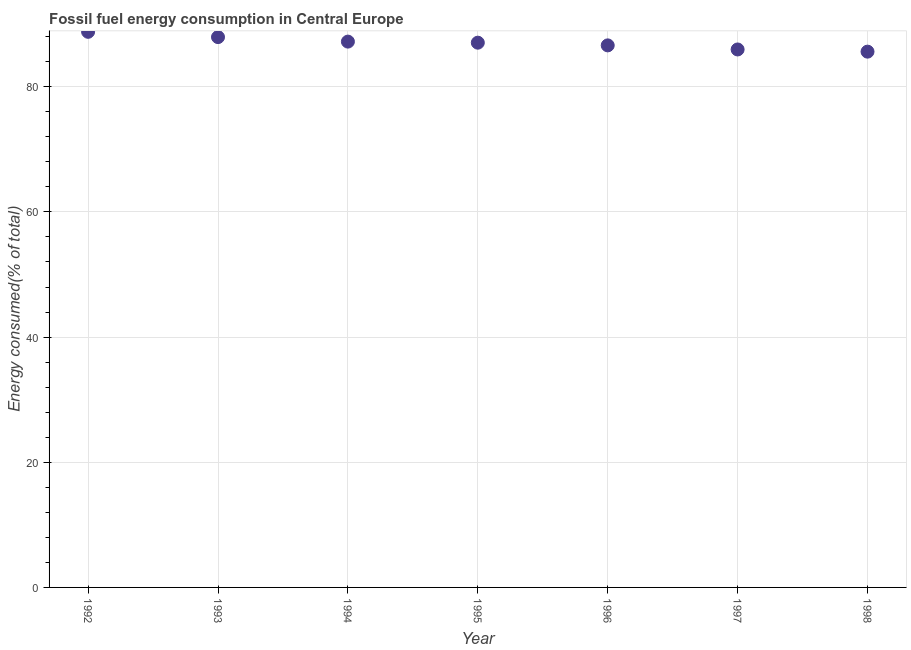What is the fossil fuel energy consumption in 1996?
Ensure brevity in your answer.  86.61. Across all years, what is the maximum fossil fuel energy consumption?
Your answer should be compact. 88.77. Across all years, what is the minimum fossil fuel energy consumption?
Provide a succinct answer. 85.61. In which year was the fossil fuel energy consumption minimum?
Give a very brief answer. 1998. What is the sum of the fossil fuel energy consumption?
Your answer should be very brief. 609.12. What is the difference between the fossil fuel energy consumption in 1993 and 1998?
Keep it short and to the point. 2.32. What is the average fossil fuel energy consumption per year?
Your response must be concise. 87.02. What is the median fossil fuel energy consumption?
Provide a short and direct response. 87.04. Do a majority of the years between 1995 and 1993 (inclusive) have fossil fuel energy consumption greater than 24 %?
Provide a short and direct response. No. What is the ratio of the fossil fuel energy consumption in 1994 to that in 1998?
Ensure brevity in your answer.  1.02. Is the fossil fuel energy consumption in 1992 less than that in 1994?
Your response must be concise. No. Is the difference between the fossil fuel energy consumption in 1996 and 1997 greater than the difference between any two years?
Keep it short and to the point. No. What is the difference between the highest and the second highest fossil fuel energy consumption?
Provide a short and direct response. 0.84. What is the difference between the highest and the lowest fossil fuel energy consumption?
Make the answer very short. 3.17. Does the fossil fuel energy consumption monotonically increase over the years?
Offer a terse response. No. How many years are there in the graph?
Your answer should be very brief. 7. What is the difference between two consecutive major ticks on the Y-axis?
Provide a short and direct response. 20. Does the graph contain any zero values?
Your answer should be compact. No. What is the title of the graph?
Your answer should be compact. Fossil fuel energy consumption in Central Europe. What is the label or title of the Y-axis?
Give a very brief answer. Energy consumed(% of total). What is the Energy consumed(% of total) in 1992?
Your answer should be very brief. 88.77. What is the Energy consumed(% of total) in 1993?
Offer a terse response. 87.93. What is the Energy consumed(% of total) in 1994?
Offer a terse response. 87.21. What is the Energy consumed(% of total) in 1995?
Your answer should be very brief. 87.04. What is the Energy consumed(% of total) in 1996?
Offer a terse response. 86.61. What is the Energy consumed(% of total) in 1997?
Provide a short and direct response. 85.95. What is the Energy consumed(% of total) in 1998?
Keep it short and to the point. 85.61. What is the difference between the Energy consumed(% of total) in 1992 and 1993?
Your answer should be compact. 0.84. What is the difference between the Energy consumed(% of total) in 1992 and 1994?
Your response must be concise. 1.56. What is the difference between the Energy consumed(% of total) in 1992 and 1995?
Offer a terse response. 1.73. What is the difference between the Energy consumed(% of total) in 1992 and 1996?
Provide a succinct answer. 2.17. What is the difference between the Energy consumed(% of total) in 1992 and 1997?
Your answer should be very brief. 2.82. What is the difference between the Energy consumed(% of total) in 1992 and 1998?
Provide a succinct answer. 3.17. What is the difference between the Energy consumed(% of total) in 1993 and 1994?
Provide a succinct answer. 0.72. What is the difference between the Energy consumed(% of total) in 1993 and 1995?
Your response must be concise. 0.89. What is the difference between the Energy consumed(% of total) in 1993 and 1996?
Provide a short and direct response. 1.32. What is the difference between the Energy consumed(% of total) in 1993 and 1997?
Keep it short and to the point. 1.98. What is the difference between the Energy consumed(% of total) in 1993 and 1998?
Offer a very short reply. 2.32. What is the difference between the Energy consumed(% of total) in 1994 and 1995?
Keep it short and to the point. 0.17. What is the difference between the Energy consumed(% of total) in 1994 and 1996?
Your answer should be very brief. 0.6. What is the difference between the Energy consumed(% of total) in 1994 and 1997?
Your response must be concise. 1.26. What is the difference between the Energy consumed(% of total) in 1994 and 1998?
Your answer should be compact. 1.6. What is the difference between the Energy consumed(% of total) in 1995 and 1996?
Keep it short and to the point. 0.43. What is the difference between the Energy consumed(% of total) in 1995 and 1997?
Provide a succinct answer. 1.09. What is the difference between the Energy consumed(% of total) in 1995 and 1998?
Provide a short and direct response. 1.43. What is the difference between the Energy consumed(% of total) in 1996 and 1997?
Provide a short and direct response. 0.65. What is the difference between the Energy consumed(% of total) in 1996 and 1998?
Offer a terse response. 1. What is the difference between the Energy consumed(% of total) in 1997 and 1998?
Offer a terse response. 0.35. What is the ratio of the Energy consumed(% of total) in 1992 to that in 1993?
Ensure brevity in your answer.  1.01. What is the ratio of the Energy consumed(% of total) in 1992 to that in 1997?
Your answer should be compact. 1.03. What is the ratio of the Energy consumed(% of total) in 1992 to that in 1998?
Offer a terse response. 1.04. What is the ratio of the Energy consumed(% of total) in 1993 to that in 1996?
Your response must be concise. 1.01. What is the ratio of the Energy consumed(% of total) in 1993 to that in 1997?
Offer a very short reply. 1.02. What is the ratio of the Energy consumed(% of total) in 1994 to that in 1996?
Give a very brief answer. 1.01. What is the ratio of the Energy consumed(% of total) in 1995 to that in 1996?
Provide a succinct answer. 1. What is the ratio of the Energy consumed(% of total) in 1995 to that in 1998?
Offer a terse response. 1.02. What is the ratio of the Energy consumed(% of total) in 1997 to that in 1998?
Your answer should be very brief. 1. 